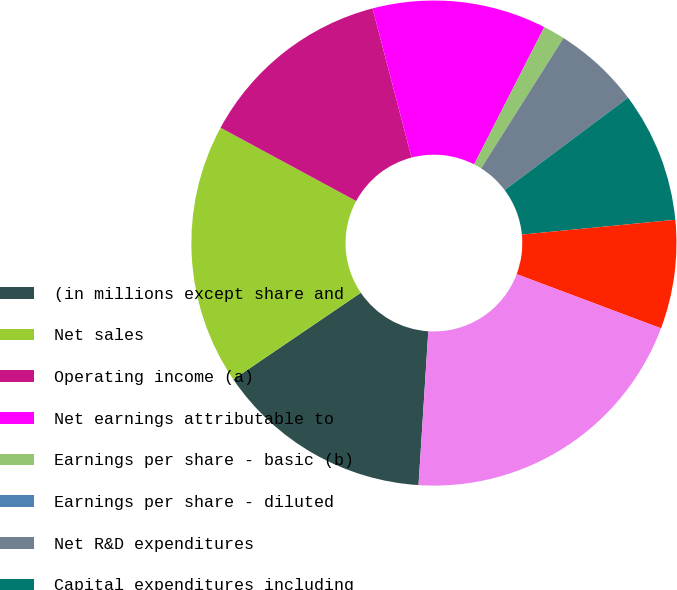<chart> <loc_0><loc_0><loc_500><loc_500><pie_chart><fcel>(in millions except share and<fcel>Net sales<fcel>Operating income (a)<fcel>Net earnings attributable to<fcel>Earnings per share - basic (b)<fcel>Earnings per share - diluted<fcel>Net R&D expenditures<fcel>Capital expenditures including<fcel>Depreciation and amortization<fcel>Number of employees<nl><fcel>14.49%<fcel>17.39%<fcel>13.04%<fcel>11.59%<fcel>1.45%<fcel>0.0%<fcel>5.8%<fcel>8.7%<fcel>7.25%<fcel>20.29%<nl></chart> 